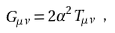Convert formula to latex. <formula><loc_0><loc_0><loc_500><loc_500>G _ { \mu \nu } = 2 \alpha ^ { 2 } T _ { \mu \nu } \ ,</formula> 